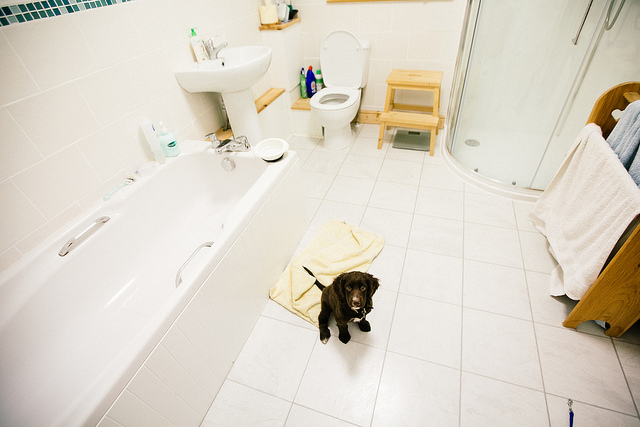<image>What kind of dog is that? I don't know the exact breed of the dog. It could possibly be a labrador, a poodle, a beagle, or a black lab. What kind of dog is that? I am not sure what kind of dog is that. It can be a labrador, lab, poodle, black dog, beagle, black lab, or a puppy. 